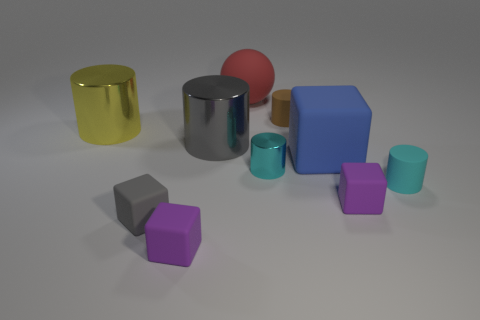Subtract all cyan metal cylinders. How many cylinders are left? 4 Subtract 4 cylinders. How many cylinders are left? 1 Subtract all spheres. How many objects are left? 9 Subtract all yellow cylinders. How many cylinders are left? 4 Subtract all green spheres. Subtract all green cylinders. How many spheres are left? 1 Subtract all yellow cubes. How many gray balls are left? 0 Add 3 small gray rubber cubes. How many small gray rubber cubes are left? 4 Add 1 blue matte blocks. How many blue matte blocks exist? 2 Subtract 0 cyan cubes. How many objects are left? 10 Subtract all tiny gray blocks. Subtract all cubes. How many objects are left? 5 